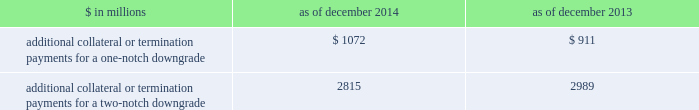Management 2019s discussion and analysis we believe our credit ratings are primarily based on the credit rating agencies 2019 assessment of : 2030 our liquidity , market , credit and operational risk management practices ; 2030 the level and variability of our earnings ; 2030 our capital base ; 2030 our franchise , reputation and management ; 2030 our corporate governance ; and 2030 the external operating environment , including , in some cases , the assumed level of government or other systemic support .
Certain of our derivatives have been transacted under bilateral agreements with counterparties who may require us to post collateral or terminate the transactions based on changes in our credit ratings .
We assess the impact of these bilateral agreements by determining the collateral or termination payments that would occur assuming a downgrade by all rating agencies .
A downgrade by any one rating agency , depending on the agency 2019s relative ratings of us at the time of the downgrade , may have an impact which is comparable to the impact of a downgrade by all rating agencies .
We allocate a portion of our gcla to ensure we would be able to make the additional collateral or termination payments that may be required in the event of a two-notch reduction in our long-term credit ratings , as well as collateral that has not been called by counterparties , but is available to them .
The table below presents the additional collateral or termination payments related to our net derivative liabilities under bilateral agreements that could have been called at the reporting date by counterparties in the event of a one-notch and two-notch downgrade in our credit ratings. .
$ in millions 2014 2013 additional collateral or termination payments for a one-notch downgrade $ 1072 $ 911 additional collateral or termination payments for a two-notch downgrade 2815 2989 cash flows as a global financial institution , our cash flows are complex and bear little relation to our net earnings and net assets .
Consequently , we believe that traditional cash flow analysis is less meaningful in evaluating our liquidity position than the liquidity and asset-liability management policies described above .
Cash flow analysis may , however , be helpful in highlighting certain macro trends and strategic initiatives in our businesses .
Year ended december 2014 .
Our cash and cash equivalents decreased by $ 3.53 billion to $ 57.60 billion at the end of 2014 .
We used $ 22.53 billion in net cash for operating and investing activities , which reflects an initiative to reduce our balance sheet , and the funding of loans receivable .
We generated $ 19.00 billion in net cash from financing activities from an increase in bank deposits and net proceeds from issuances of unsecured long-term borrowings , partially offset by repurchases of common stock .
Year ended december 2013 .
Our cash and cash equivalents decreased by $ 11.54 billion to $ 61.13 billion at the end of 2013 .
We generated $ 4.54 billion in net cash from operating activities .
We used net cash of $ 16.08 billion for investing and financing activities , primarily to fund loans receivable and repurchases of common stock .
Year ended december 2012 .
Our cash and cash equivalents increased by $ 16.66 billion to $ 72.67 billion at the end of 2012 .
We generated $ 9.14 billion in net cash from operating and investing activities .
We generated $ 7.52 billion in net cash from financing activities from an increase in bank deposits , partially offset by net repayments of unsecured and secured long-term borrowings .
78 goldman sachs 2014 annual report .
For the year ended december 2013 in billions , what was the balance of cash and cash equivalents? 
Computations: (57.60 - 3.53)
Answer: 54.07. 